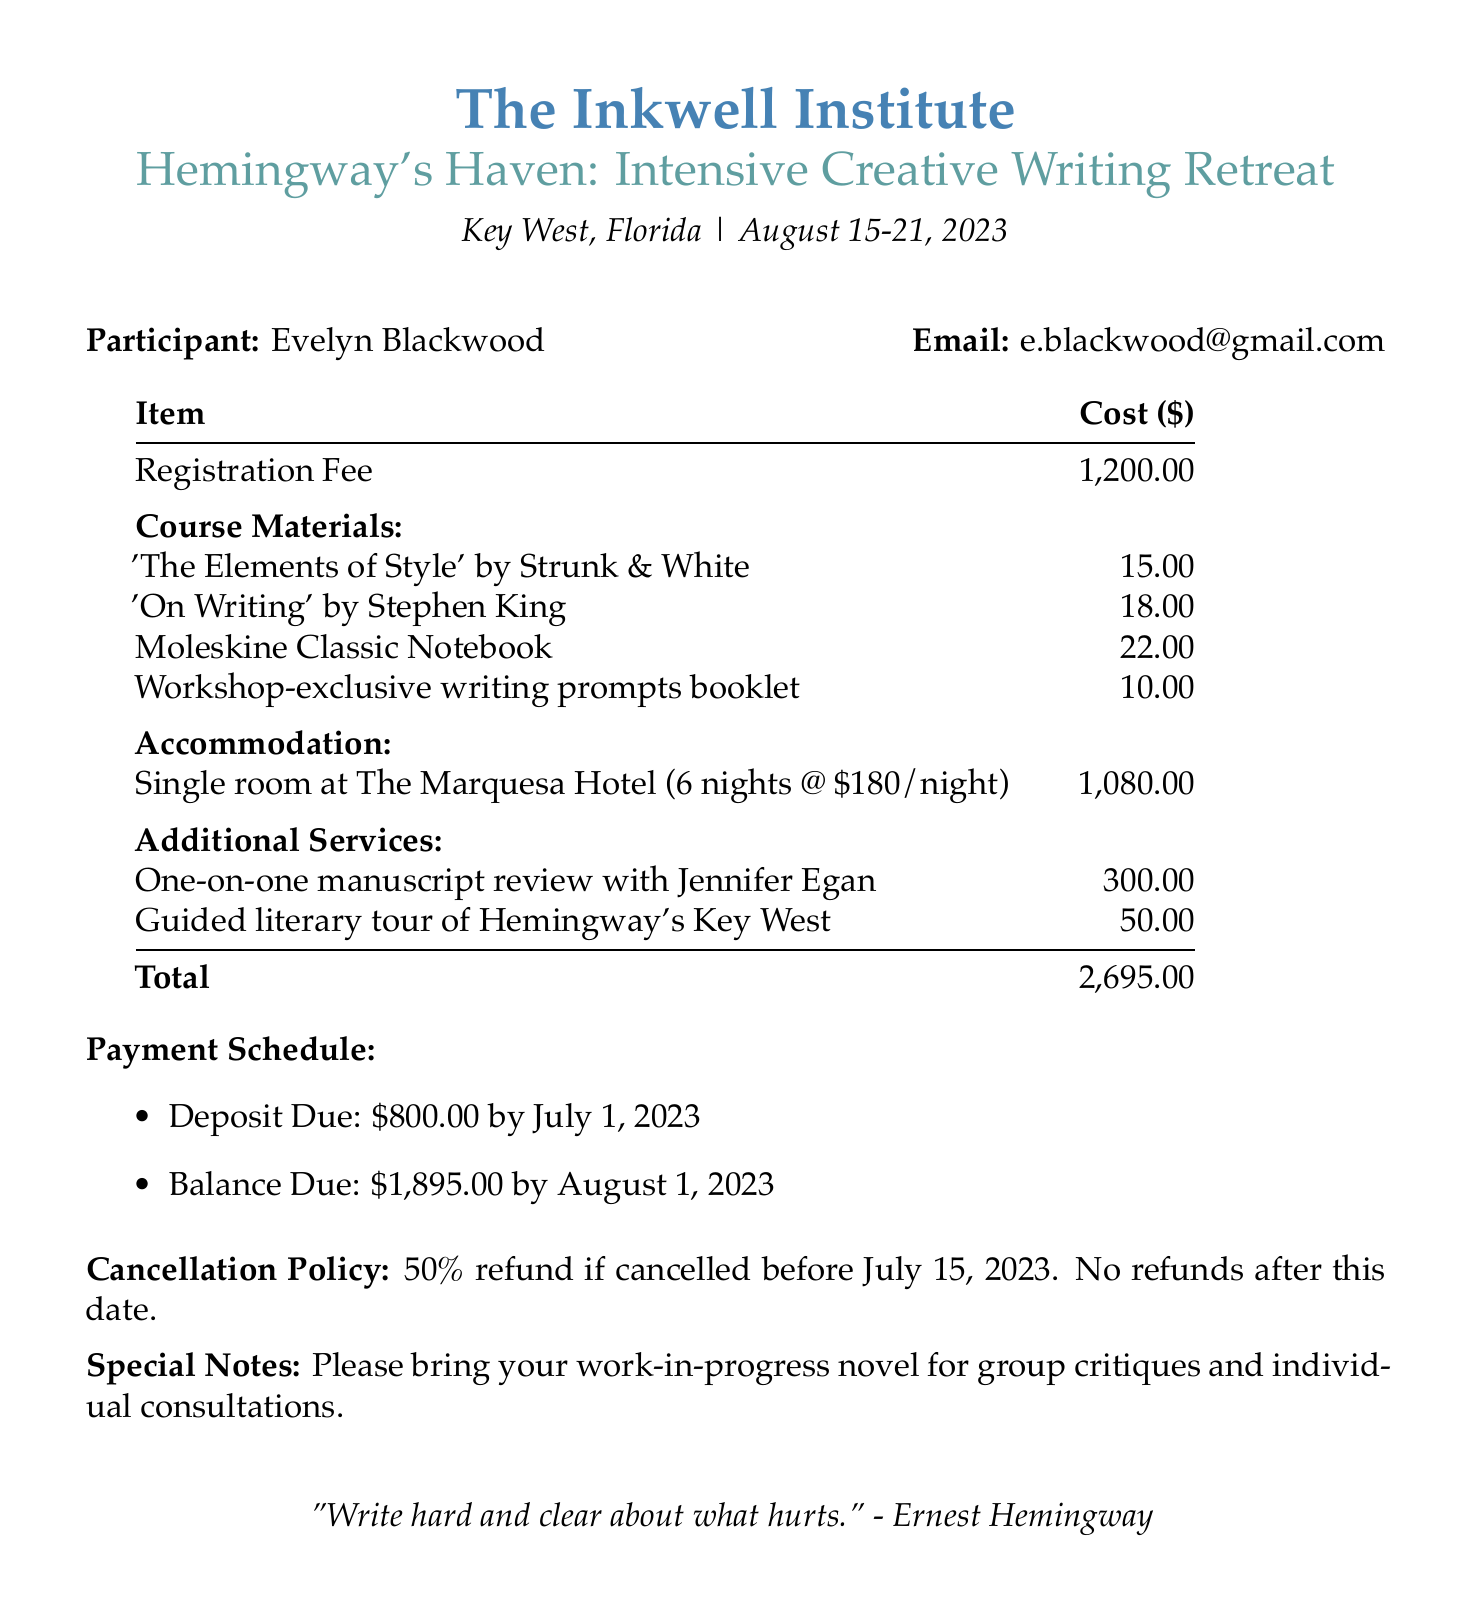What is the name of the workshop? The name of the workshop is listed at the top of the document under the workshop details.
Answer: Hemingway's Haven: Intensive Creative Writing Retreat Who is the organizer of the workshop? The organizer's name is mentioned right below the workshop name.
Answer: The Inkwell Institute What are the dates of the workshop? The dates are stated prominently in the workshop details section.
Answer: August 15-21, 2023 What is the total amount due for the workshop? The total amount is provided in the payment details section of the document.
Answer: 2695 What is the accommodation type mentioned in the document? The accommodation type is specified under the accommodation section.
Answer: Single room at The Marquesa Hotel What is the price per night for accommodation? The price per night is detailed within the accommodation description.
Answer: 180 What is the deposit due date? The deposit due date is listed under the payment schedule.
Answer: July 1, 2023 What refund policy is stated for cancellations? The cancellation policy is clearly outlined in the document.
Answer: 50% refund if cancelled before July 15, 2023 What special note is mentioned for participants? The special notes section provides specific instructions for participants.
Answer: Please bring your work-in-progress novel for group critiques and individual consultations 